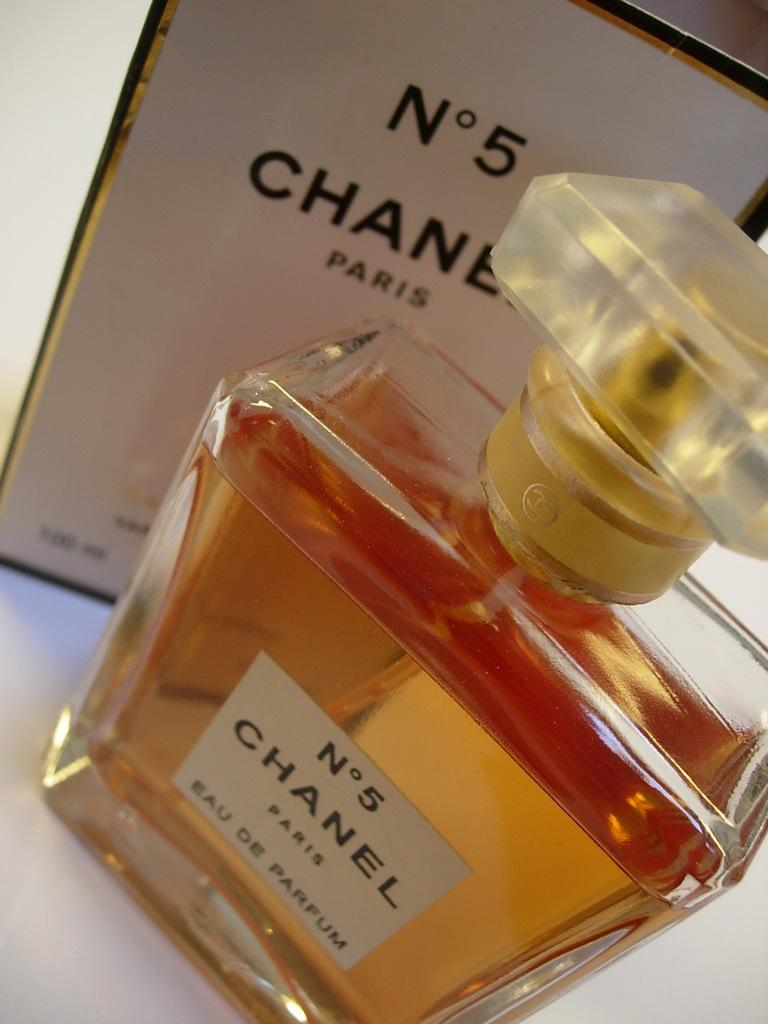<image>
Present a compact description of the photo's key features. A bottle of Chanel No. 5 sits in front of its box. 